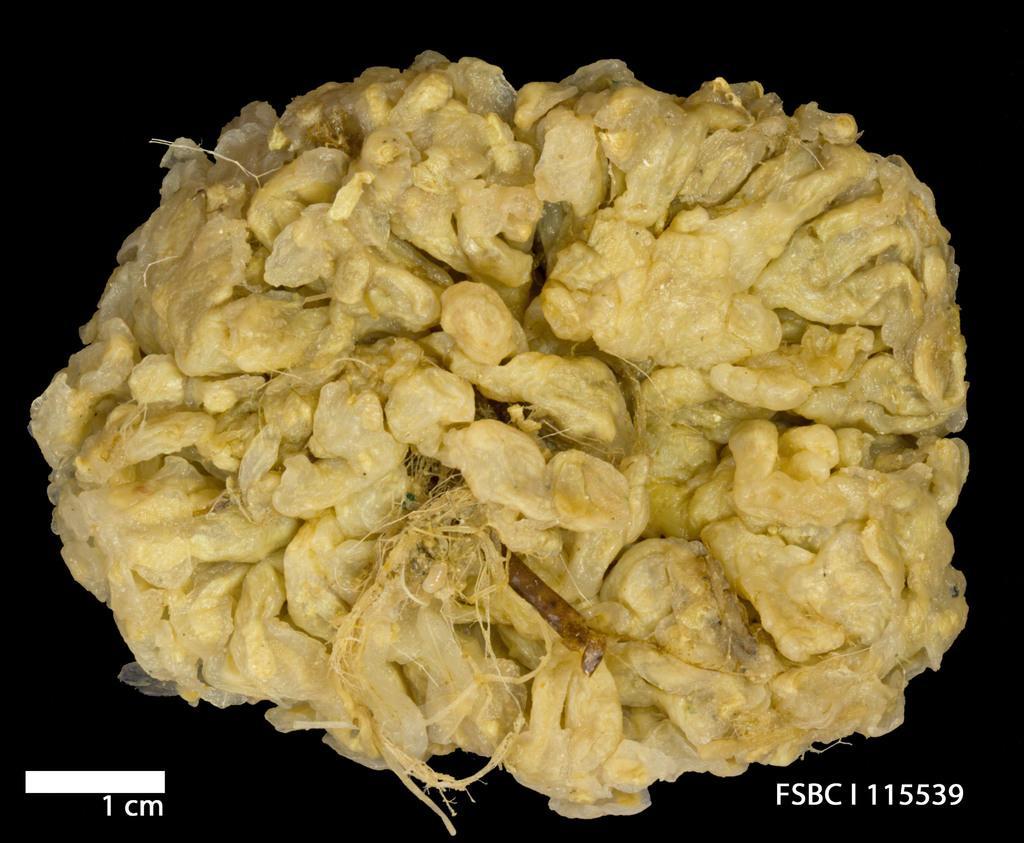Can you describe this image briefly? In this image there is some food. 